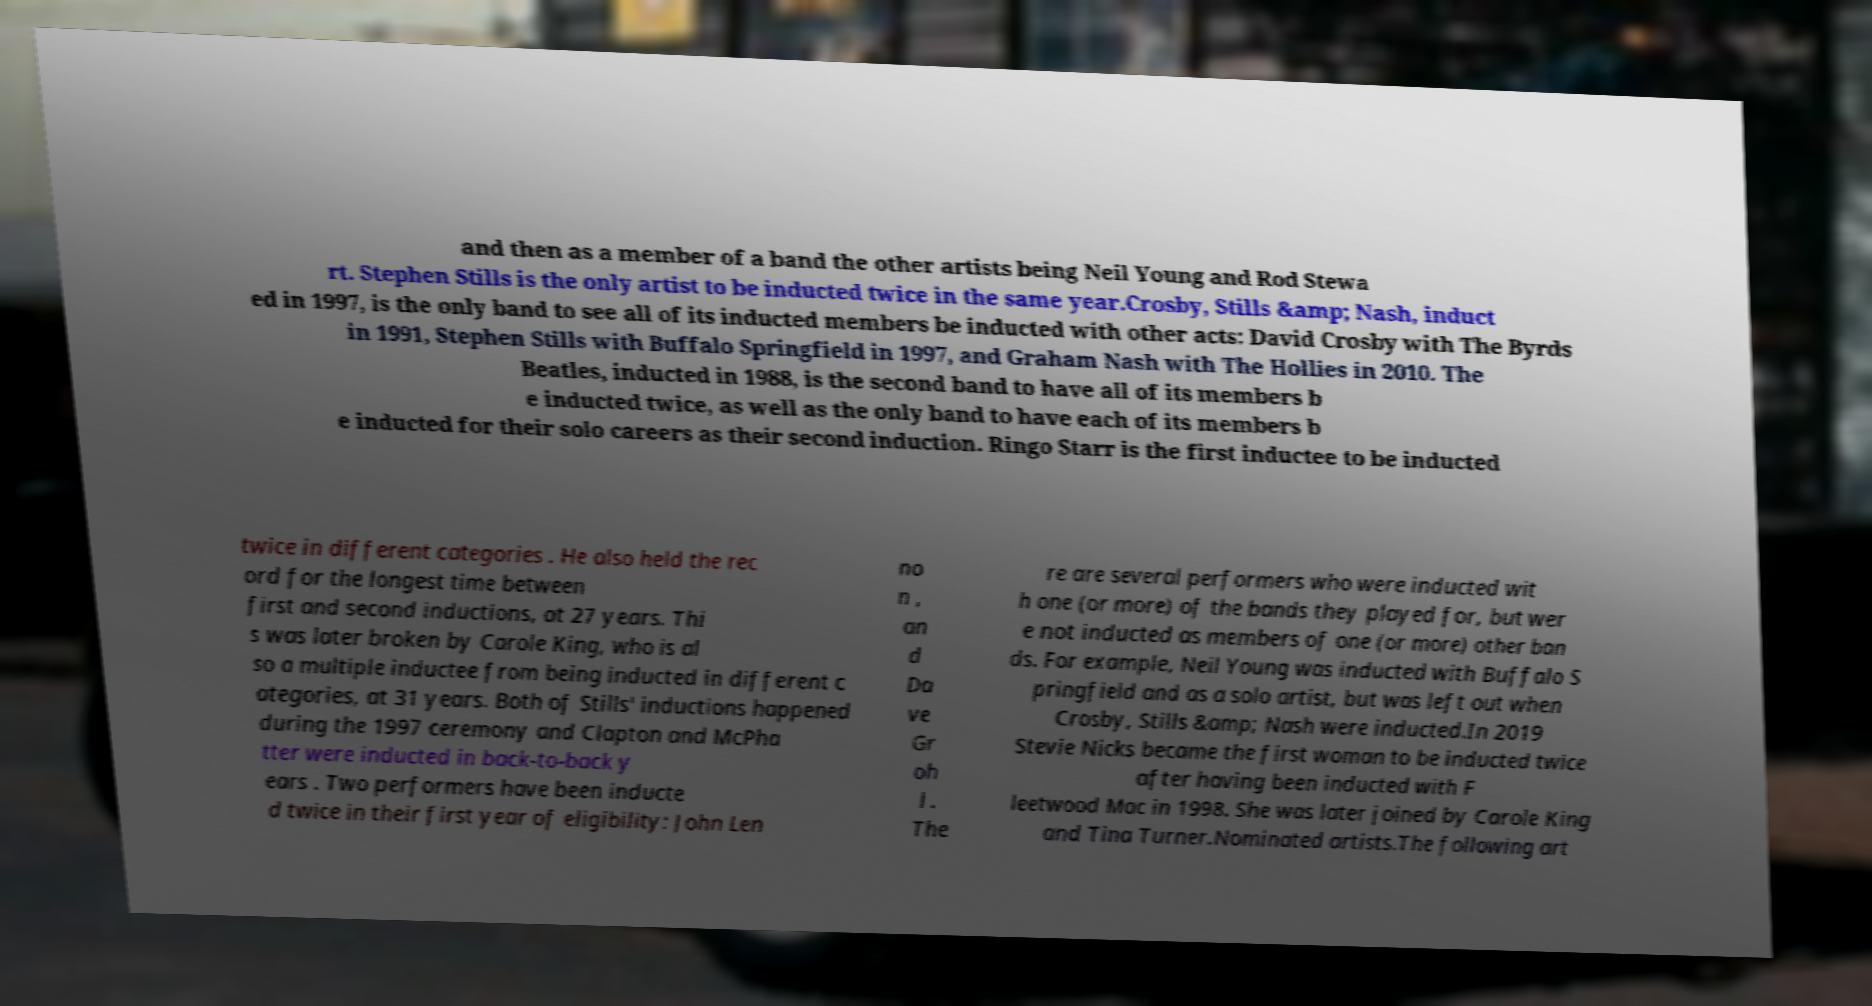I need the written content from this picture converted into text. Can you do that? and then as a member of a band the other artists being Neil Young and Rod Stewa rt. Stephen Stills is the only artist to be inducted twice in the same year.Crosby, Stills &amp; Nash, induct ed in 1997, is the only band to see all of its inducted members be inducted with other acts: David Crosby with The Byrds in 1991, Stephen Stills with Buffalo Springfield in 1997, and Graham Nash with The Hollies in 2010. The Beatles, inducted in 1988, is the second band to have all of its members b e inducted twice, as well as the only band to have each of its members b e inducted for their solo careers as their second induction. Ringo Starr is the first inductee to be inducted twice in different categories . He also held the rec ord for the longest time between first and second inductions, at 27 years. Thi s was later broken by Carole King, who is al so a multiple inductee from being inducted in different c ategories, at 31 years. Both of Stills' inductions happened during the 1997 ceremony and Clapton and McPha tter were inducted in back-to-back y ears . Two performers have been inducte d twice in their first year of eligibility: John Len no n , an d Da ve Gr oh l . The re are several performers who were inducted wit h one (or more) of the bands they played for, but wer e not inducted as members of one (or more) other ban ds. For example, Neil Young was inducted with Buffalo S pringfield and as a solo artist, but was left out when Crosby, Stills &amp; Nash were inducted.In 2019 Stevie Nicks became the first woman to be inducted twice after having been inducted with F leetwood Mac in 1998. She was later joined by Carole King and Tina Turner.Nominated artists.The following art 